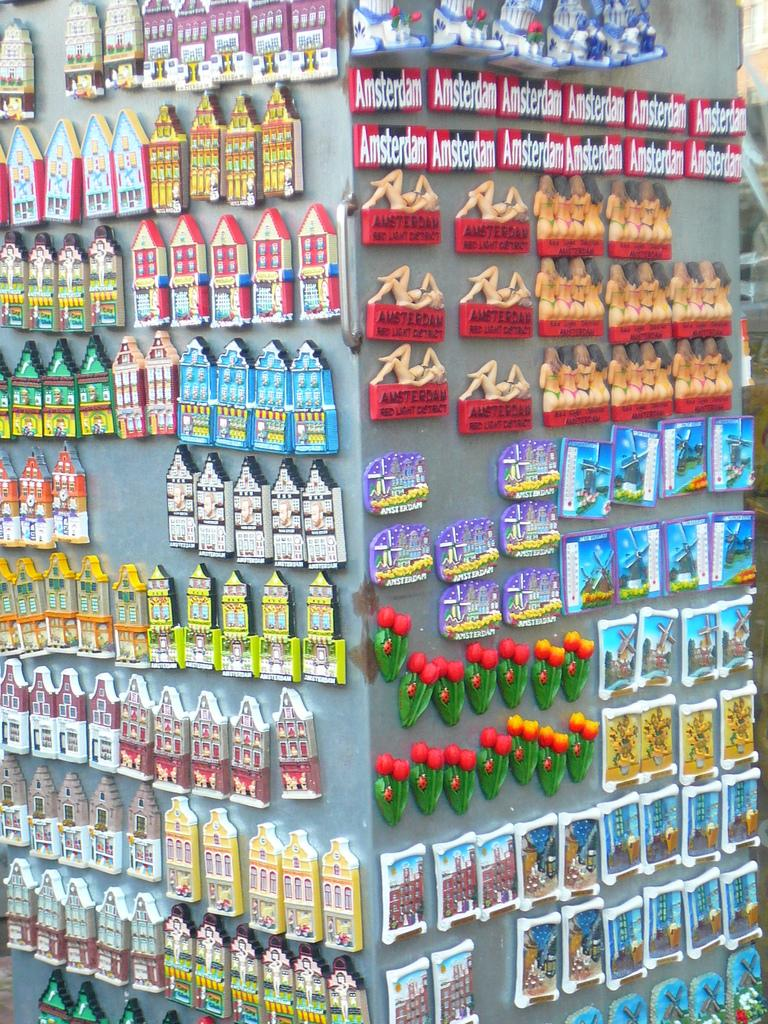<image>
Offer a succinct explanation of the picture presented. Many magnets that say Amsterdam are just above magnets of women in bathing suits. 